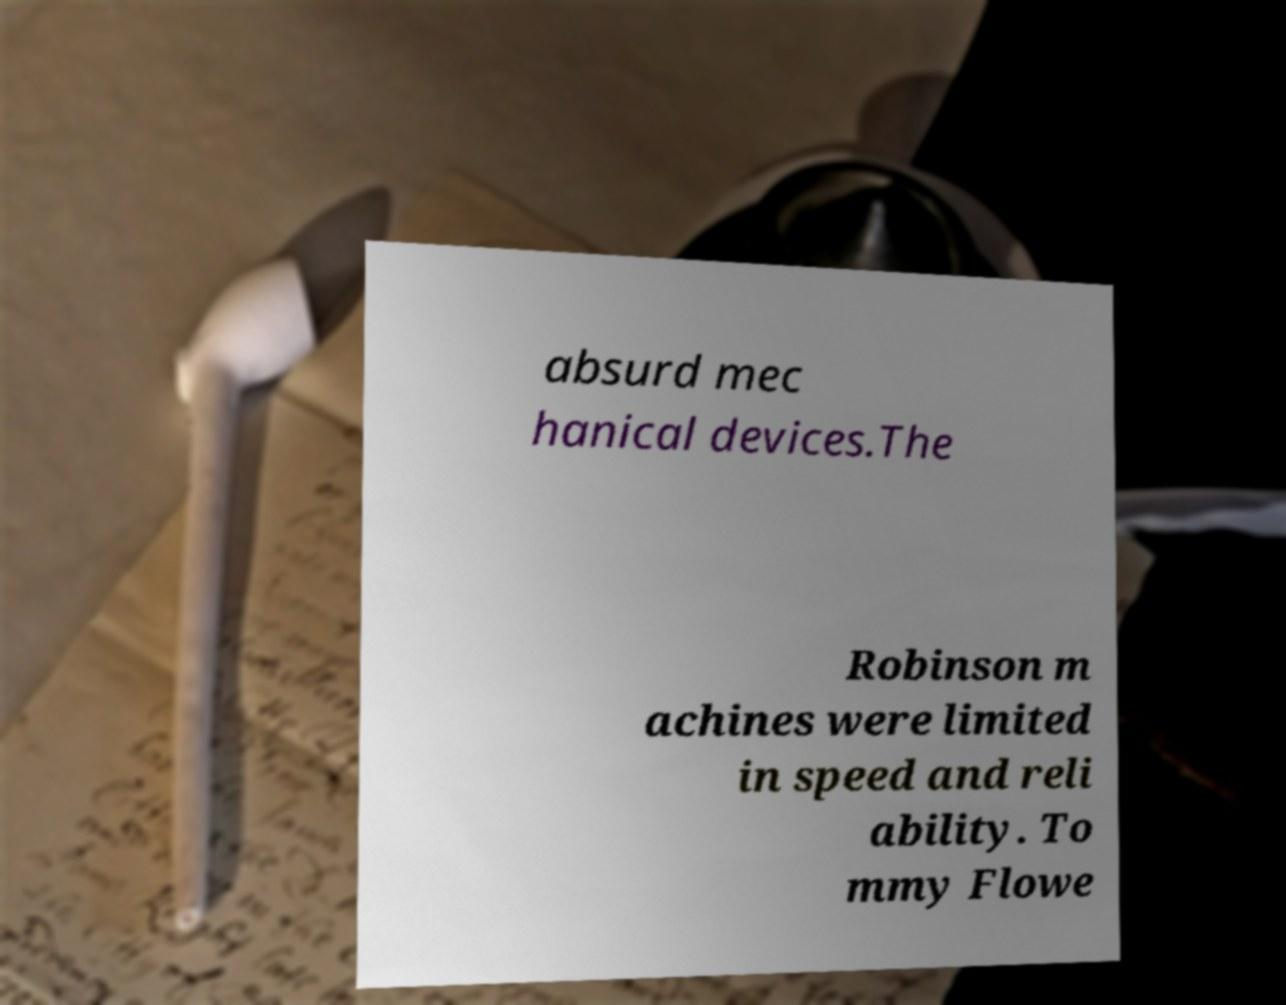Could you extract and type out the text from this image? absurd mec hanical devices.The Robinson m achines were limited in speed and reli ability. To mmy Flowe 